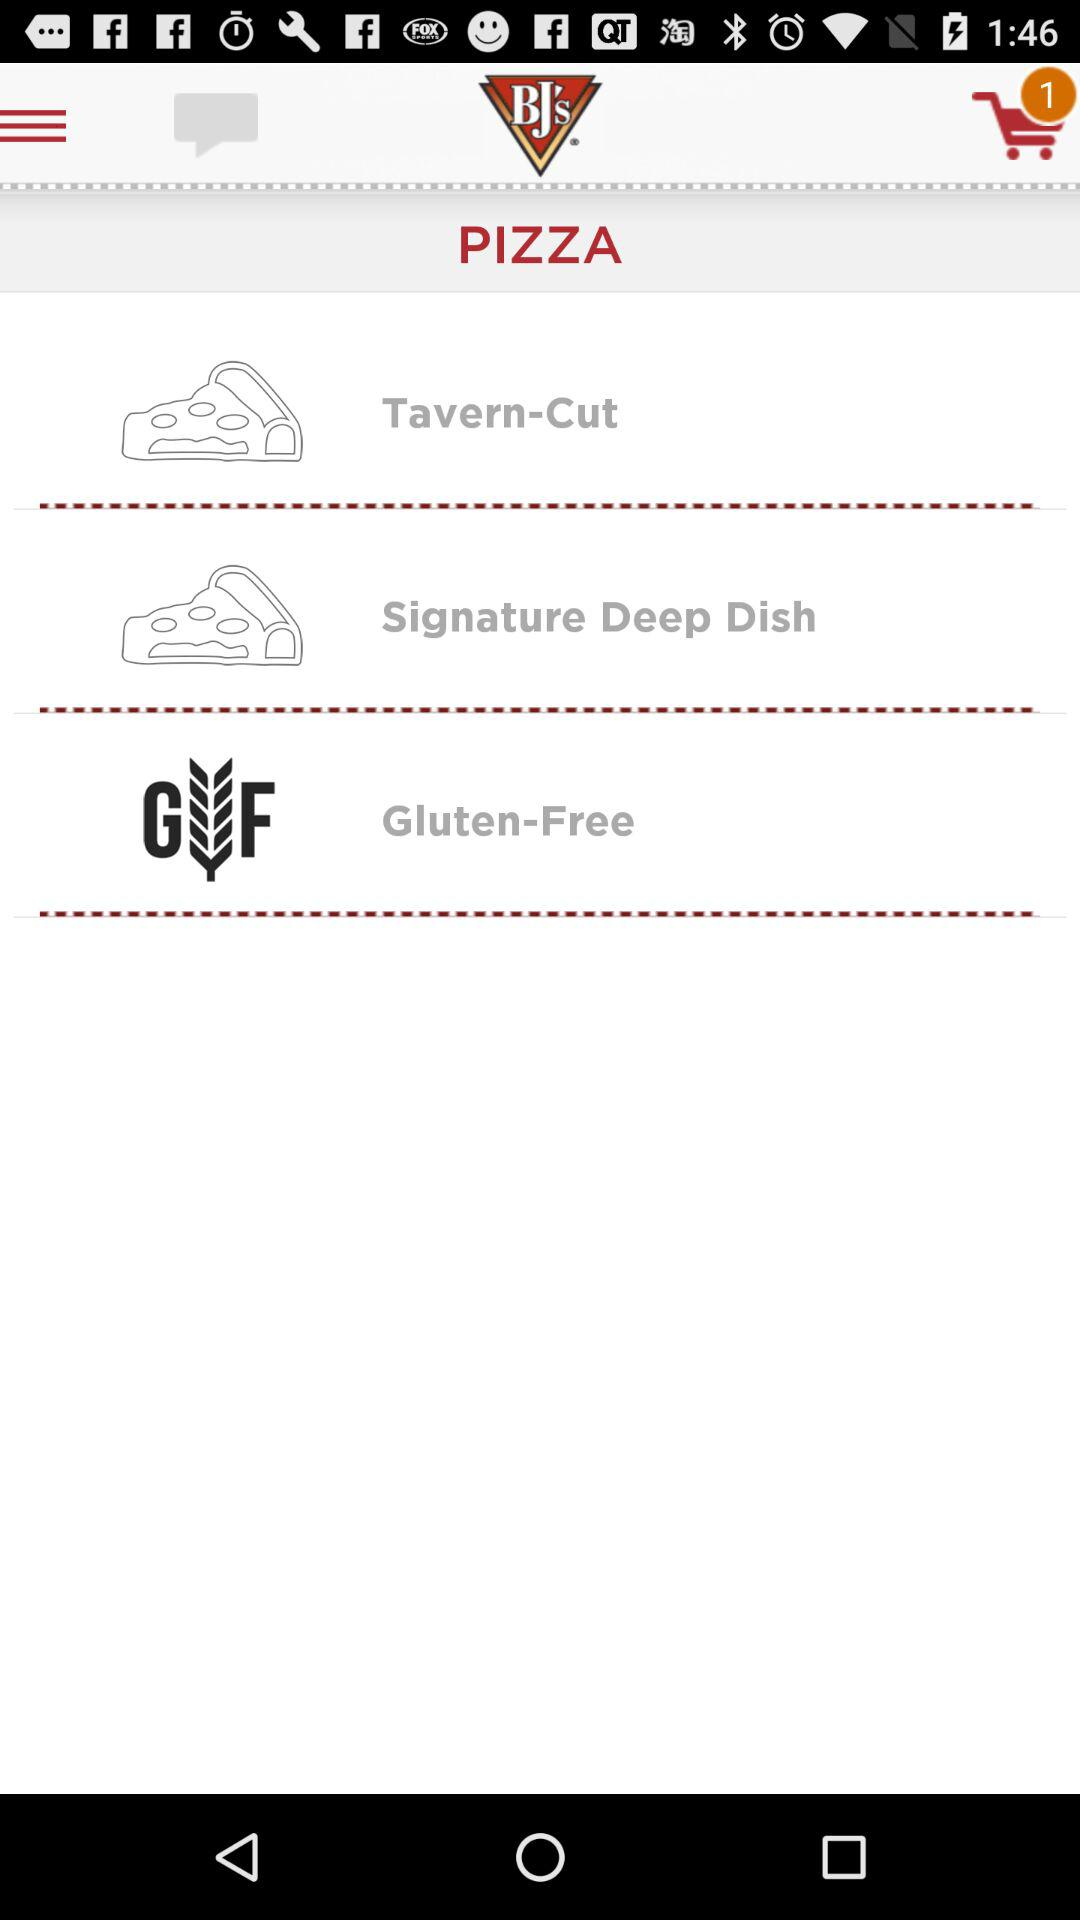How many orders are there in the cart? There is 1 order in the cart. 